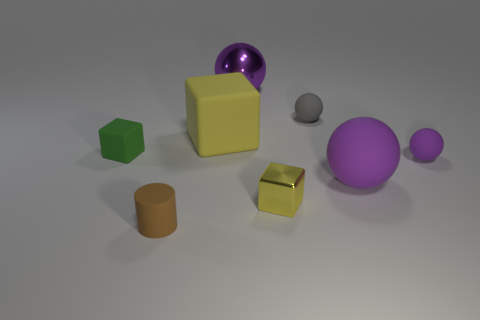There is a object that is behind the yellow rubber object and left of the tiny gray object; what material is it?
Offer a very short reply. Metal. Are there fewer big purple matte balls than big things?
Your answer should be compact. Yes. Is the shape of the tiny gray matte object the same as the big metal object on the right side of the rubber cylinder?
Offer a very short reply. Yes. Do the matte ball that is behind the green rubber cube and the brown cylinder have the same size?
Offer a very short reply. Yes. There is a purple thing that is the same size as the yellow shiny cube; what shape is it?
Provide a succinct answer. Sphere. Is the small green thing the same shape as the yellow matte object?
Give a very brief answer. Yes. How many purple matte objects are the same shape as the tiny gray rubber thing?
Keep it short and to the point. 2. What number of tiny yellow blocks are behind the purple metal object?
Your answer should be compact. 0. Is the color of the small block that is left of the brown cylinder the same as the big block?
Keep it short and to the point. No. How many brown rubber objects are the same size as the shiny cube?
Offer a terse response. 1. 